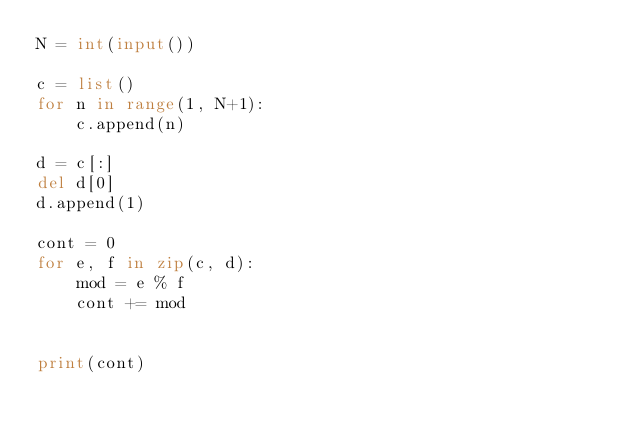<code> <loc_0><loc_0><loc_500><loc_500><_Python_>N = int(input())

c = list()
for n in range(1, N+1):
    c.append(n)

d = c[:]
del d[0]
d.append(1)

cont = 0
for e, f in zip(c, d):
    mod = e % f
    cont += mod


print(cont)</code> 